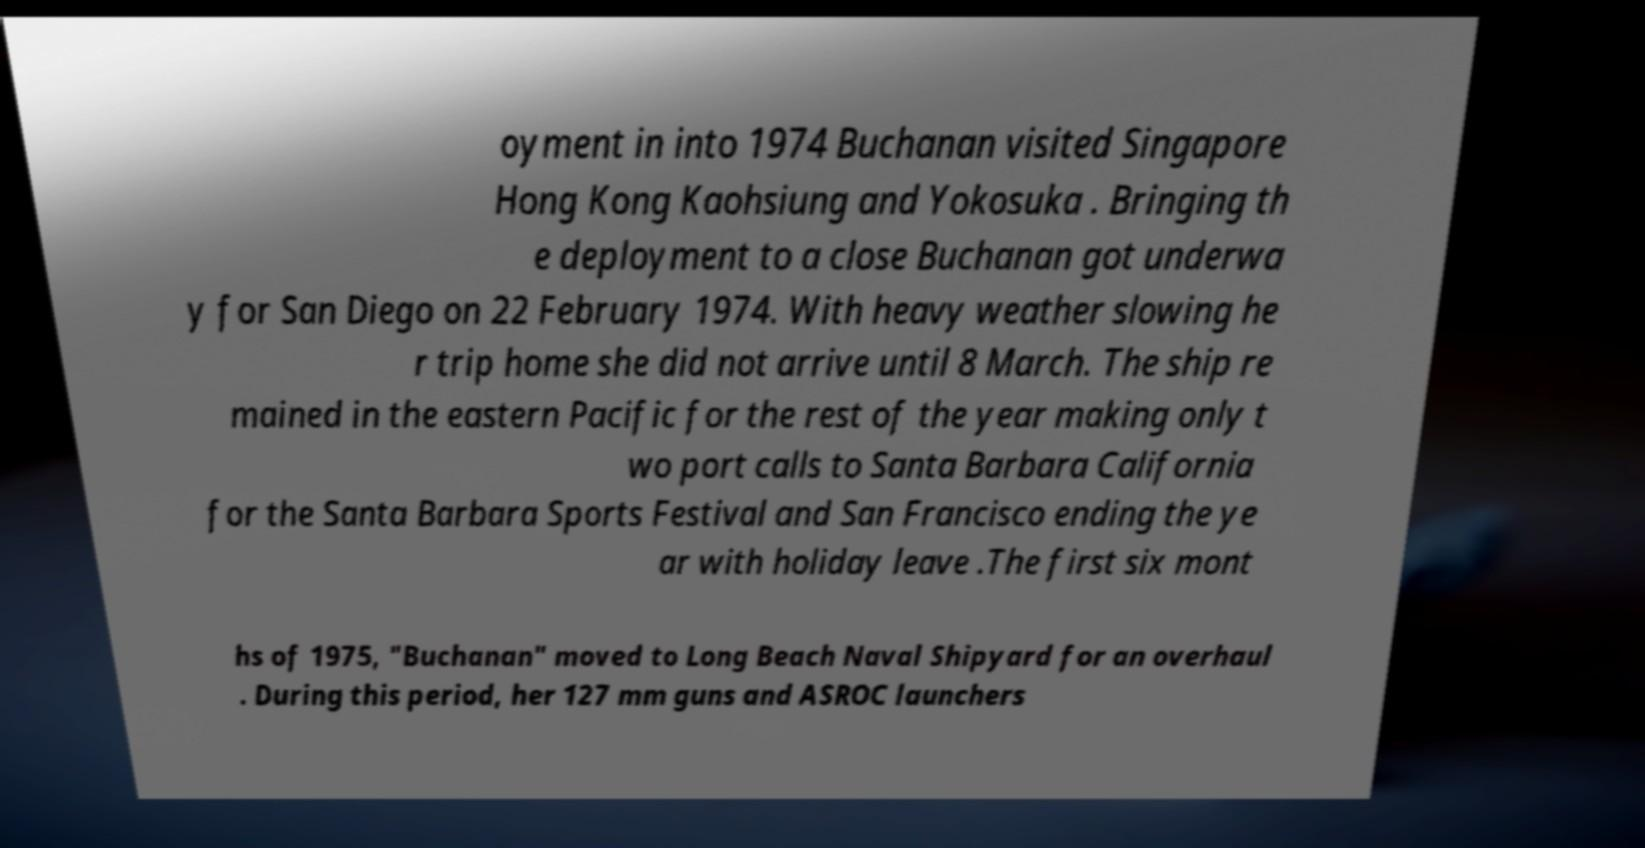Could you assist in decoding the text presented in this image and type it out clearly? oyment in into 1974 Buchanan visited Singapore Hong Kong Kaohsiung and Yokosuka . Bringing th e deployment to a close Buchanan got underwa y for San Diego on 22 February 1974. With heavy weather slowing he r trip home she did not arrive until 8 March. The ship re mained in the eastern Pacific for the rest of the year making only t wo port calls to Santa Barbara California for the Santa Barbara Sports Festival and San Francisco ending the ye ar with holiday leave .The first six mont hs of 1975, "Buchanan" moved to Long Beach Naval Shipyard for an overhaul . During this period, her 127 mm guns and ASROC launchers 